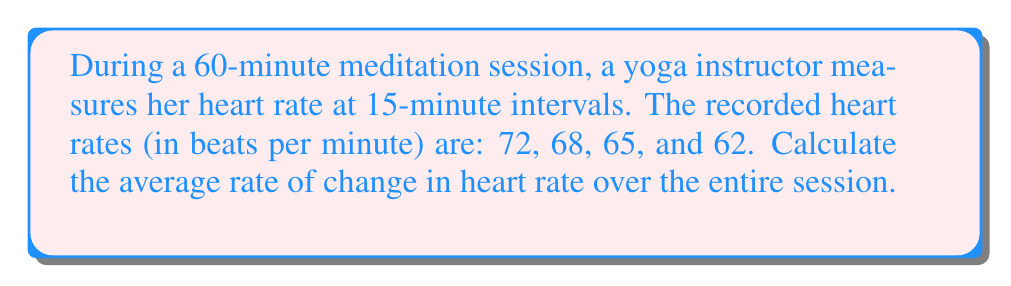Show me your answer to this math problem. To calculate the average rate of change in heart rate over the entire session, we'll use the formula:

$$\text{Average rate of change} = \frac{\text{Change in y}}{\text{Change in x}} = \frac{\Delta y}{\Delta x}$$

Step 1: Identify the initial and final values
* Initial heart rate (at t = 0 min): 72 bpm
* Final heart rate (at t = 60 min): 62 bpm
* Total time: 60 minutes

Step 2: Calculate the change in heart rate (Δy)
$$\Delta y = \text{Final heart rate} - \text{Initial heart rate}$$
$$\Delta y = 62 - 72 = -10 \text{ bpm}$$

Step 3: Calculate the change in time (Δx)
$$\Delta x = 60 \text{ minutes} = 1 \text{ hour}$$

Step 4: Apply the average rate of change formula
$$\text{Average rate of change} = \frac{\Delta y}{\Delta x} = \frac{-10 \text{ bpm}}{1 \text{ hour}} = -10 \text{ bpm/hour}$$

The negative sign indicates that the heart rate is decreasing over time.
Answer: $-10 \text{ bpm/hour}$ 